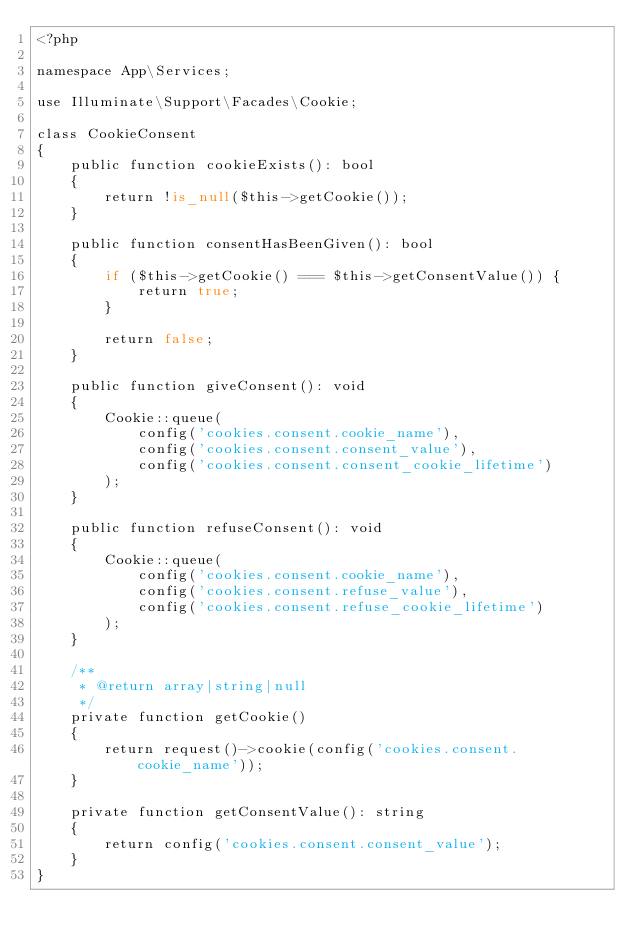<code> <loc_0><loc_0><loc_500><loc_500><_PHP_><?php

namespace App\Services;

use Illuminate\Support\Facades\Cookie;

class CookieConsent
{
    public function cookieExists(): bool
    {
        return !is_null($this->getCookie());
    }

    public function consentHasBeenGiven(): bool
    {
        if ($this->getCookie() === $this->getConsentValue()) {
            return true;
        }

        return false;
    }

    public function giveConsent(): void
    {
        Cookie::queue(
            config('cookies.consent.cookie_name'),
            config('cookies.consent.consent_value'),
            config('cookies.consent.consent_cookie_lifetime')
        );
    }

    public function refuseConsent(): void
    {
        Cookie::queue(
            config('cookies.consent.cookie_name'),
            config('cookies.consent.refuse_value'),
            config('cookies.consent.refuse_cookie_lifetime')
        );
    }

    /**
     * @return array|string|null
     */
    private function getCookie()
    {
        return request()->cookie(config('cookies.consent.cookie_name'));
    }

    private function getConsentValue(): string
    {
        return config('cookies.consent.consent_value');
    }
}
</code> 